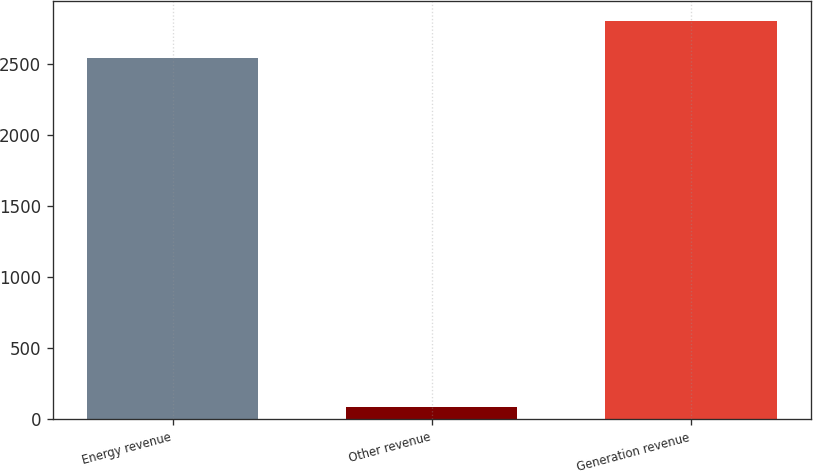Convert chart. <chart><loc_0><loc_0><loc_500><loc_500><bar_chart><fcel>Energy revenue<fcel>Other revenue<fcel>Generation revenue<nl><fcel>2545<fcel>86<fcel>2802.3<nl></chart> 